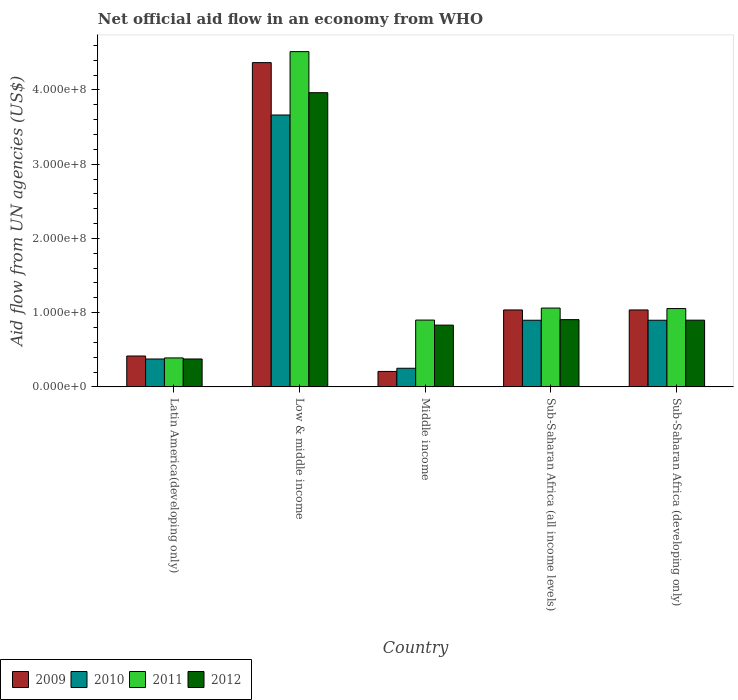How many different coloured bars are there?
Make the answer very short. 4. Are the number of bars per tick equal to the number of legend labels?
Give a very brief answer. Yes. How many bars are there on the 5th tick from the right?
Provide a short and direct response. 4. What is the label of the 4th group of bars from the left?
Your answer should be compact. Sub-Saharan Africa (all income levels). What is the net official aid flow in 2009 in Sub-Saharan Africa (developing only)?
Ensure brevity in your answer.  1.04e+08. Across all countries, what is the maximum net official aid flow in 2009?
Ensure brevity in your answer.  4.37e+08. Across all countries, what is the minimum net official aid flow in 2012?
Ensure brevity in your answer.  3.76e+07. In which country was the net official aid flow in 2011 minimum?
Provide a short and direct response. Latin America(developing only). What is the total net official aid flow in 2010 in the graph?
Give a very brief answer. 6.08e+08. What is the difference between the net official aid flow in 2012 in Latin America(developing only) and that in Sub-Saharan Africa (all income levels)?
Offer a terse response. -5.30e+07. What is the difference between the net official aid flow in 2011 in Low & middle income and the net official aid flow in 2009 in Middle income?
Provide a short and direct response. 4.31e+08. What is the average net official aid flow in 2012 per country?
Offer a very short reply. 1.39e+08. What is the difference between the net official aid flow of/in 2010 and net official aid flow of/in 2009 in Middle income?
Provide a succinct answer. 4.27e+06. What is the ratio of the net official aid flow in 2009 in Latin America(developing only) to that in Sub-Saharan Africa (all income levels)?
Give a very brief answer. 0.4. Is the net official aid flow in 2011 in Low & middle income less than that in Middle income?
Your answer should be very brief. No. What is the difference between the highest and the second highest net official aid flow in 2010?
Your answer should be very brief. 2.76e+08. What is the difference between the highest and the lowest net official aid flow in 2012?
Offer a terse response. 3.59e+08. In how many countries, is the net official aid flow in 2012 greater than the average net official aid flow in 2012 taken over all countries?
Keep it short and to the point. 1. What does the 3rd bar from the left in Sub-Saharan Africa (developing only) represents?
Your response must be concise. 2011. How many countries are there in the graph?
Your answer should be compact. 5. Are the values on the major ticks of Y-axis written in scientific E-notation?
Offer a very short reply. Yes. Does the graph contain any zero values?
Keep it short and to the point. No. Does the graph contain grids?
Make the answer very short. No. How many legend labels are there?
Provide a short and direct response. 4. How are the legend labels stacked?
Keep it short and to the point. Horizontal. What is the title of the graph?
Give a very brief answer. Net official aid flow in an economy from WHO. What is the label or title of the X-axis?
Provide a succinct answer. Country. What is the label or title of the Y-axis?
Ensure brevity in your answer.  Aid flow from UN agencies (US$). What is the Aid flow from UN agencies (US$) in 2009 in Latin America(developing only)?
Keep it short and to the point. 4.16e+07. What is the Aid flow from UN agencies (US$) in 2010 in Latin America(developing only)?
Offer a terse response. 3.76e+07. What is the Aid flow from UN agencies (US$) in 2011 in Latin America(developing only)?
Your response must be concise. 3.90e+07. What is the Aid flow from UN agencies (US$) of 2012 in Latin America(developing only)?
Provide a short and direct response. 3.76e+07. What is the Aid flow from UN agencies (US$) of 2009 in Low & middle income?
Your answer should be very brief. 4.37e+08. What is the Aid flow from UN agencies (US$) in 2010 in Low & middle income?
Keep it short and to the point. 3.66e+08. What is the Aid flow from UN agencies (US$) of 2011 in Low & middle income?
Keep it short and to the point. 4.52e+08. What is the Aid flow from UN agencies (US$) of 2012 in Low & middle income?
Keep it short and to the point. 3.96e+08. What is the Aid flow from UN agencies (US$) of 2009 in Middle income?
Offer a very short reply. 2.08e+07. What is the Aid flow from UN agencies (US$) in 2010 in Middle income?
Provide a succinct answer. 2.51e+07. What is the Aid flow from UN agencies (US$) of 2011 in Middle income?
Your answer should be compact. 9.00e+07. What is the Aid flow from UN agencies (US$) in 2012 in Middle income?
Ensure brevity in your answer.  8.32e+07. What is the Aid flow from UN agencies (US$) in 2009 in Sub-Saharan Africa (all income levels)?
Offer a very short reply. 1.04e+08. What is the Aid flow from UN agencies (US$) of 2010 in Sub-Saharan Africa (all income levels)?
Provide a short and direct response. 8.98e+07. What is the Aid flow from UN agencies (US$) in 2011 in Sub-Saharan Africa (all income levels)?
Provide a short and direct response. 1.06e+08. What is the Aid flow from UN agencies (US$) of 2012 in Sub-Saharan Africa (all income levels)?
Keep it short and to the point. 9.06e+07. What is the Aid flow from UN agencies (US$) of 2009 in Sub-Saharan Africa (developing only)?
Your answer should be compact. 1.04e+08. What is the Aid flow from UN agencies (US$) in 2010 in Sub-Saharan Africa (developing only)?
Your answer should be compact. 8.98e+07. What is the Aid flow from UN agencies (US$) in 2011 in Sub-Saharan Africa (developing only)?
Provide a short and direct response. 1.05e+08. What is the Aid flow from UN agencies (US$) in 2012 in Sub-Saharan Africa (developing only)?
Provide a short and direct response. 8.98e+07. Across all countries, what is the maximum Aid flow from UN agencies (US$) of 2009?
Ensure brevity in your answer.  4.37e+08. Across all countries, what is the maximum Aid flow from UN agencies (US$) in 2010?
Provide a succinct answer. 3.66e+08. Across all countries, what is the maximum Aid flow from UN agencies (US$) of 2011?
Keep it short and to the point. 4.52e+08. Across all countries, what is the maximum Aid flow from UN agencies (US$) in 2012?
Offer a terse response. 3.96e+08. Across all countries, what is the minimum Aid flow from UN agencies (US$) of 2009?
Your response must be concise. 2.08e+07. Across all countries, what is the minimum Aid flow from UN agencies (US$) in 2010?
Keep it short and to the point. 2.51e+07. Across all countries, what is the minimum Aid flow from UN agencies (US$) in 2011?
Give a very brief answer. 3.90e+07. Across all countries, what is the minimum Aid flow from UN agencies (US$) of 2012?
Give a very brief answer. 3.76e+07. What is the total Aid flow from UN agencies (US$) of 2009 in the graph?
Give a very brief answer. 7.06e+08. What is the total Aid flow from UN agencies (US$) of 2010 in the graph?
Provide a short and direct response. 6.08e+08. What is the total Aid flow from UN agencies (US$) in 2011 in the graph?
Offer a terse response. 7.92e+08. What is the total Aid flow from UN agencies (US$) in 2012 in the graph?
Your response must be concise. 6.97e+08. What is the difference between the Aid flow from UN agencies (US$) of 2009 in Latin America(developing only) and that in Low & middle income?
Provide a succinct answer. -3.95e+08. What is the difference between the Aid flow from UN agencies (US$) in 2010 in Latin America(developing only) and that in Low & middle income?
Provide a short and direct response. -3.29e+08. What is the difference between the Aid flow from UN agencies (US$) in 2011 in Latin America(developing only) and that in Low & middle income?
Make the answer very short. -4.13e+08. What is the difference between the Aid flow from UN agencies (US$) in 2012 in Latin America(developing only) and that in Low & middle income?
Ensure brevity in your answer.  -3.59e+08. What is the difference between the Aid flow from UN agencies (US$) in 2009 in Latin America(developing only) and that in Middle income?
Make the answer very short. 2.08e+07. What is the difference between the Aid flow from UN agencies (US$) in 2010 in Latin America(developing only) and that in Middle income?
Offer a terse response. 1.25e+07. What is the difference between the Aid flow from UN agencies (US$) of 2011 in Latin America(developing only) and that in Middle income?
Provide a succinct answer. -5.10e+07. What is the difference between the Aid flow from UN agencies (US$) of 2012 in Latin America(developing only) and that in Middle income?
Give a very brief answer. -4.56e+07. What is the difference between the Aid flow from UN agencies (US$) in 2009 in Latin America(developing only) and that in Sub-Saharan Africa (all income levels)?
Your answer should be compact. -6.20e+07. What is the difference between the Aid flow from UN agencies (US$) in 2010 in Latin America(developing only) and that in Sub-Saharan Africa (all income levels)?
Keep it short and to the point. -5.22e+07. What is the difference between the Aid flow from UN agencies (US$) in 2011 in Latin America(developing only) and that in Sub-Saharan Africa (all income levels)?
Your answer should be very brief. -6.72e+07. What is the difference between the Aid flow from UN agencies (US$) in 2012 in Latin America(developing only) and that in Sub-Saharan Africa (all income levels)?
Provide a short and direct response. -5.30e+07. What is the difference between the Aid flow from UN agencies (US$) of 2009 in Latin America(developing only) and that in Sub-Saharan Africa (developing only)?
Provide a short and direct response. -6.20e+07. What is the difference between the Aid flow from UN agencies (US$) of 2010 in Latin America(developing only) and that in Sub-Saharan Africa (developing only)?
Your answer should be compact. -5.22e+07. What is the difference between the Aid flow from UN agencies (US$) in 2011 in Latin America(developing only) and that in Sub-Saharan Africa (developing only)?
Keep it short and to the point. -6.65e+07. What is the difference between the Aid flow from UN agencies (US$) of 2012 in Latin America(developing only) and that in Sub-Saharan Africa (developing only)?
Your answer should be compact. -5.23e+07. What is the difference between the Aid flow from UN agencies (US$) in 2009 in Low & middle income and that in Middle income?
Offer a very short reply. 4.16e+08. What is the difference between the Aid flow from UN agencies (US$) of 2010 in Low & middle income and that in Middle income?
Provide a short and direct response. 3.41e+08. What is the difference between the Aid flow from UN agencies (US$) in 2011 in Low & middle income and that in Middle income?
Your answer should be compact. 3.62e+08. What is the difference between the Aid flow from UN agencies (US$) of 2012 in Low & middle income and that in Middle income?
Provide a succinct answer. 3.13e+08. What is the difference between the Aid flow from UN agencies (US$) in 2009 in Low & middle income and that in Sub-Saharan Africa (all income levels)?
Your response must be concise. 3.33e+08. What is the difference between the Aid flow from UN agencies (US$) in 2010 in Low & middle income and that in Sub-Saharan Africa (all income levels)?
Your answer should be compact. 2.76e+08. What is the difference between the Aid flow from UN agencies (US$) in 2011 in Low & middle income and that in Sub-Saharan Africa (all income levels)?
Make the answer very short. 3.45e+08. What is the difference between the Aid flow from UN agencies (US$) of 2012 in Low & middle income and that in Sub-Saharan Africa (all income levels)?
Ensure brevity in your answer.  3.06e+08. What is the difference between the Aid flow from UN agencies (US$) in 2009 in Low & middle income and that in Sub-Saharan Africa (developing only)?
Make the answer very short. 3.33e+08. What is the difference between the Aid flow from UN agencies (US$) of 2010 in Low & middle income and that in Sub-Saharan Africa (developing only)?
Your answer should be compact. 2.76e+08. What is the difference between the Aid flow from UN agencies (US$) in 2011 in Low & middle income and that in Sub-Saharan Africa (developing only)?
Provide a short and direct response. 3.46e+08. What is the difference between the Aid flow from UN agencies (US$) in 2012 in Low & middle income and that in Sub-Saharan Africa (developing only)?
Your answer should be very brief. 3.06e+08. What is the difference between the Aid flow from UN agencies (US$) of 2009 in Middle income and that in Sub-Saharan Africa (all income levels)?
Your answer should be very brief. -8.28e+07. What is the difference between the Aid flow from UN agencies (US$) of 2010 in Middle income and that in Sub-Saharan Africa (all income levels)?
Make the answer very short. -6.47e+07. What is the difference between the Aid flow from UN agencies (US$) in 2011 in Middle income and that in Sub-Saharan Africa (all income levels)?
Your response must be concise. -1.62e+07. What is the difference between the Aid flow from UN agencies (US$) in 2012 in Middle income and that in Sub-Saharan Africa (all income levels)?
Your answer should be very brief. -7.39e+06. What is the difference between the Aid flow from UN agencies (US$) in 2009 in Middle income and that in Sub-Saharan Africa (developing only)?
Your response must be concise. -8.28e+07. What is the difference between the Aid flow from UN agencies (US$) of 2010 in Middle income and that in Sub-Saharan Africa (developing only)?
Give a very brief answer. -6.47e+07. What is the difference between the Aid flow from UN agencies (US$) in 2011 in Middle income and that in Sub-Saharan Africa (developing only)?
Provide a succinct answer. -1.55e+07. What is the difference between the Aid flow from UN agencies (US$) of 2012 in Middle income and that in Sub-Saharan Africa (developing only)?
Offer a very short reply. -6.67e+06. What is the difference between the Aid flow from UN agencies (US$) in 2009 in Sub-Saharan Africa (all income levels) and that in Sub-Saharan Africa (developing only)?
Provide a succinct answer. 0. What is the difference between the Aid flow from UN agencies (US$) in 2010 in Sub-Saharan Africa (all income levels) and that in Sub-Saharan Africa (developing only)?
Offer a very short reply. 0. What is the difference between the Aid flow from UN agencies (US$) of 2011 in Sub-Saharan Africa (all income levels) and that in Sub-Saharan Africa (developing only)?
Ensure brevity in your answer.  6.70e+05. What is the difference between the Aid flow from UN agencies (US$) in 2012 in Sub-Saharan Africa (all income levels) and that in Sub-Saharan Africa (developing only)?
Your answer should be very brief. 7.20e+05. What is the difference between the Aid flow from UN agencies (US$) of 2009 in Latin America(developing only) and the Aid flow from UN agencies (US$) of 2010 in Low & middle income?
Offer a terse response. -3.25e+08. What is the difference between the Aid flow from UN agencies (US$) of 2009 in Latin America(developing only) and the Aid flow from UN agencies (US$) of 2011 in Low & middle income?
Offer a terse response. -4.10e+08. What is the difference between the Aid flow from UN agencies (US$) of 2009 in Latin America(developing only) and the Aid flow from UN agencies (US$) of 2012 in Low & middle income?
Your answer should be compact. -3.55e+08. What is the difference between the Aid flow from UN agencies (US$) of 2010 in Latin America(developing only) and the Aid flow from UN agencies (US$) of 2011 in Low & middle income?
Your response must be concise. -4.14e+08. What is the difference between the Aid flow from UN agencies (US$) of 2010 in Latin America(developing only) and the Aid flow from UN agencies (US$) of 2012 in Low & middle income?
Provide a short and direct response. -3.59e+08. What is the difference between the Aid flow from UN agencies (US$) in 2011 in Latin America(developing only) and the Aid flow from UN agencies (US$) in 2012 in Low & middle income?
Your response must be concise. -3.57e+08. What is the difference between the Aid flow from UN agencies (US$) of 2009 in Latin America(developing only) and the Aid flow from UN agencies (US$) of 2010 in Middle income?
Keep it short and to the point. 1.65e+07. What is the difference between the Aid flow from UN agencies (US$) of 2009 in Latin America(developing only) and the Aid flow from UN agencies (US$) of 2011 in Middle income?
Offer a very short reply. -4.84e+07. What is the difference between the Aid flow from UN agencies (US$) in 2009 in Latin America(developing only) and the Aid flow from UN agencies (US$) in 2012 in Middle income?
Ensure brevity in your answer.  -4.16e+07. What is the difference between the Aid flow from UN agencies (US$) of 2010 in Latin America(developing only) and the Aid flow from UN agencies (US$) of 2011 in Middle income?
Your response must be concise. -5.24e+07. What is the difference between the Aid flow from UN agencies (US$) of 2010 in Latin America(developing only) and the Aid flow from UN agencies (US$) of 2012 in Middle income?
Give a very brief answer. -4.56e+07. What is the difference between the Aid flow from UN agencies (US$) of 2011 in Latin America(developing only) and the Aid flow from UN agencies (US$) of 2012 in Middle income?
Provide a succinct answer. -4.42e+07. What is the difference between the Aid flow from UN agencies (US$) in 2009 in Latin America(developing only) and the Aid flow from UN agencies (US$) in 2010 in Sub-Saharan Africa (all income levels)?
Keep it short and to the point. -4.82e+07. What is the difference between the Aid flow from UN agencies (US$) in 2009 in Latin America(developing only) and the Aid flow from UN agencies (US$) in 2011 in Sub-Saharan Africa (all income levels)?
Your answer should be compact. -6.46e+07. What is the difference between the Aid flow from UN agencies (US$) in 2009 in Latin America(developing only) and the Aid flow from UN agencies (US$) in 2012 in Sub-Saharan Africa (all income levels)?
Your answer should be compact. -4.90e+07. What is the difference between the Aid flow from UN agencies (US$) of 2010 in Latin America(developing only) and the Aid flow from UN agencies (US$) of 2011 in Sub-Saharan Africa (all income levels)?
Provide a short and direct response. -6.86e+07. What is the difference between the Aid flow from UN agencies (US$) in 2010 in Latin America(developing only) and the Aid flow from UN agencies (US$) in 2012 in Sub-Saharan Africa (all income levels)?
Give a very brief answer. -5.30e+07. What is the difference between the Aid flow from UN agencies (US$) of 2011 in Latin America(developing only) and the Aid flow from UN agencies (US$) of 2012 in Sub-Saharan Africa (all income levels)?
Make the answer very short. -5.16e+07. What is the difference between the Aid flow from UN agencies (US$) in 2009 in Latin America(developing only) and the Aid flow from UN agencies (US$) in 2010 in Sub-Saharan Africa (developing only)?
Offer a very short reply. -4.82e+07. What is the difference between the Aid flow from UN agencies (US$) in 2009 in Latin America(developing only) and the Aid flow from UN agencies (US$) in 2011 in Sub-Saharan Africa (developing only)?
Give a very brief answer. -6.39e+07. What is the difference between the Aid flow from UN agencies (US$) in 2009 in Latin America(developing only) and the Aid flow from UN agencies (US$) in 2012 in Sub-Saharan Africa (developing only)?
Your response must be concise. -4.83e+07. What is the difference between the Aid flow from UN agencies (US$) of 2010 in Latin America(developing only) and the Aid flow from UN agencies (US$) of 2011 in Sub-Saharan Africa (developing only)?
Offer a terse response. -6.79e+07. What is the difference between the Aid flow from UN agencies (US$) in 2010 in Latin America(developing only) and the Aid flow from UN agencies (US$) in 2012 in Sub-Saharan Africa (developing only)?
Your answer should be compact. -5.23e+07. What is the difference between the Aid flow from UN agencies (US$) of 2011 in Latin America(developing only) and the Aid flow from UN agencies (US$) of 2012 in Sub-Saharan Africa (developing only)?
Your answer should be compact. -5.09e+07. What is the difference between the Aid flow from UN agencies (US$) of 2009 in Low & middle income and the Aid flow from UN agencies (US$) of 2010 in Middle income?
Offer a terse response. 4.12e+08. What is the difference between the Aid flow from UN agencies (US$) in 2009 in Low & middle income and the Aid flow from UN agencies (US$) in 2011 in Middle income?
Your answer should be very brief. 3.47e+08. What is the difference between the Aid flow from UN agencies (US$) in 2009 in Low & middle income and the Aid flow from UN agencies (US$) in 2012 in Middle income?
Your answer should be compact. 3.54e+08. What is the difference between the Aid flow from UN agencies (US$) in 2010 in Low & middle income and the Aid flow from UN agencies (US$) in 2011 in Middle income?
Keep it short and to the point. 2.76e+08. What is the difference between the Aid flow from UN agencies (US$) in 2010 in Low & middle income and the Aid flow from UN agencies (US$) in 2012 in Middle income?
Offer a terse response. 2.83e+08. What is the difference between the Aid flow from UN agencies (US$) of 2011 in Low & middle income and the Aid flow from UN agencies (US$) of 2012 in Middle income?
Keep it short and to the point. 3.68e+08. What is the difference between the Aid flow from UN agencies (US$) in 2009 in Low & middle income and the Aid flow from UN agencies (US$) in 2010 in Sub-Saharan Africa (all income levels)?
Ensure brevity in your answer.  3.47e+08. What is the difference between the Aid flow from UN agencies (US$) of 2009 in Low & middle income and the Aid flow from UN agencies (US$) of 2011 in Sub-Saharan Africa (all income levels)?
Provide a short and direct response. 3.31e+08. What is the difference between the Aid flow from UN agencies (US$) in 2009 in Low & middle income and the Aid flow from UN agencies (US$) in 2012 in Sub-Saharan Africa (all income levels)?
Give a very brief answer. 3.46e+08. What is the difference between the Aid flow from UN agencies (US$) of 2010 in Low & middle income and the Aid flow from UN agencies (US$) of 2011 in Sub-Saharan Africa (all income levels)?
Offer a very short reply. 2.60e+08. What is the difference between the Aid flow from UN agencies (US$) of 2010 in Low & middle income and the Aid flow from UN agencies (US$) of 2012 in Sub-Saharan Africa (all income levels)?
Keep it short and to the point. 2.76e+08. What is the difference between the Aid flow from UN agencies (US$) in 2011 in Low & middle income and the Aid flow from UN agencies (US$) in 2012 in Sub-Saharan Africa (all income levels)?
Your answer should be very brief. 3.61e+08. What is the difference between the Aid flow from UN agencies (US$) of 2009 in Low & middle income and the Aid flow from UN agencies (US$) of 2010 in Sub-Saharan Africa (developing only)?
Offer a very short reply. 3.47e+08. What is the difference between the Aid flow from UN agencies (US$) in 2009 in Low & middle income and the Aid flow from UN agencies (US$) in 2011 in Sub-Saharan Africa (developing only)?
Give a very brief answer. 3.31e+08. What is the difference between the Aid flow from UN agencies (US$) in 2009 in Low & middle income and the Aid flow from UN agencies (US$) in 2012 in Sub-Saharan Africa (developing only)?
Make the answer very short. 3.47e+08. What is the difference between the Aid flow from UN agencies (US$) in 2010 in Low & middle income and the Aid flow from UN agencies (US$) in 2011 in Sub-Saharan Africa (developing only)?
Give a very brief answer. 2.61e+08. What is the difference between the Aid flow from UN agencies (US$) of 2010 in Low & middle income and the Aid flow from UN agencies (US$) of 2012 in Sub-Saharan Africa (developing only)?
Give a very brief answer. 2.76e+08. What is the difference between the Aid flow from UN agencies (US$) of 2011 in Low & middle income and the Aid flow from UN agencies (US$) of 2012 in Sub-Saharan Africa (developing only)?
Keep it short and to the point. 3.62e+08. What is the difference between the Aid flow from UN agencies (US$) in 2009 in Middle income and the Aid flow from UN agencies (US$) in 2010 in Sub-Saharan Africa (all income levels)?
Provide a succinct answer. -6.90e+07. What is the difference between the Aid flow from UN agencies (US$) of 2009 in Middle income and the Aid flow from UN agencies (US$) of 2011 in Sub-Saharan Africa (all income levels)?
Offer a very short reply. -8.54e+07. What is the difference between the Aid flow from UN agencies (US$) in 2009 in Middle income and the Aid flow from UN agencies (US$) in 2012 in Sub-Saharan Africa (all income levels)?
Your response must be concise. -6.98e+07. What is the difference between the Aid flow from UN agencies (US$) of 2010 in Middle income and the Aid flow from UN agencies (US$) of 2011 in Sub-Saharan Africa (all income levels)?
Offer a terse response. -8.11e+07. What is the difference between the Aid flow from UN agencies (US$) of 2010 in Middle income and the Aid flow from UN agencies (US$) of 2012 in Sub-Saharan Africa (all income levels)?
Your answer should be very brief. -6.55e+07. What is the difference between the Aid flow from UN agencies (US$) of 2011 in Middle income and the Aid flow from UN agencies (US$) of 2012 in Sub-Saharan Africa (all income levels)?
Provide a succinct answer. -5.90e+05. What is the difference between the Aid flow from UN agencies (US$) in 2009 in Middle income and the Aid flow from UN agencies (US$) in 2010 in Sub-Saharan Africa (developing only)?
Offer a terse response. -6.90e+07. What is the difference between the Aid flow from UN agencies (US$) in 2009 in Middle income and the Aid flow from UN agencies (US$) in 2011 in Sub-Saharan Africa (developing only)?
Offer a terse response. -8.47e+07. What is the difference between the Aid flow from UN agencies (US$) of 2009 in Middle income and the Aid flow from UN agencies (US$) of 2012 in Sub-Saharan Africa (developing only)?
Your answer should be very brief. -6.90e+07. What is the difference between the Aid flow from UN agencies (US$) of 2010 in Middle income and the Aid flow from UN agencies (US$) of 2011 in Sub-Saharan Africa (developing only)?
Offer a terse response. -8.04e+07. What is the difference between the Aid flow from UN agencies (US$) in 2010 in Middle income and the Aid flow from UN agencies (US$) in 2012 in Sub-Saharan Africa (developing only)?
Provide a succinct answer. -6.48e+07. What is the difference between the Aid flow from UN agencies (US$) of 2011 in Middle income and the Aid flow from UN agencies (US$) of 2012 in Sub-Saharan Africa (developing only)?
Your answer should be very brief. 1.30e+05. What is the difference between the Aid flow from UN agencies (US$) of 2009 in Sub-Saharan Africa (all income levels) and the Aid flow from UN agencies (US$) of 2010 in Sub-Saharan Africa (developing only)?
Your answer should be very brief. 1.39e+07. What is the difference between the Aid flow from UN agencies (US$) of 2009 in Sub-Saharan Africa (all income levels) and the Aid flow from UN agencies (US$) of 2011 in Sub-Saharan Africa (developing only)?
Offer a very short reply. -1.86e+06. What is the difference between the Aid flow from UN agencies (US$) in 2009 in Sub-Saharan Africa (all income levels) and the Aid flow from UN agencies (US$) in 2012 in Sub-Saharan Africa (developing only)?
Your answer should be compact. 1.38e+07. What is the difference between the Aid flow from UN agencies (US$) of 2010 in Sub-Saharan Africa (all income levels) and the Aid flow from UN agencies (US$) of 2011 in Sub-Saharan Africa (developing only)?
Make the answer very short. -1.57e+07. What is the difference between the Aid flow from UN agencies (US$) in 2010 in Sub-Saharan Africa (all income levels) and the Aid flow from UN agencies (US$) in 2012 in Sub-Saharan Africa (developing only)?
Give a very brief answer. -9.00e+04. What is the difference between the Aid flow from UN agencies (US$) of 2011 in Sub-Saharan Africa (all income levels) and the Aid flow from UN agencies (US$) of 2012 in Sub-Saharan Africa (developing only)?
Provide a succinct answer. 1.63e+07. What is the average Aid flow from UN agencies (US$) of 2009 per country?
Provide a short and direct response. 1.41e+08. What is the average Aid flow from UN agencies (US$) in 2010 per country?
Keep it short and to the point. 1.22e+08. What is the average Aid flow from UN agencies (US$) of 2011 per country?
Ensure brevity in your answer.  1.58e+08. What is the average Aid flow from UN agencies (US$) of 2012 per country?
Your response must be concise. 1.39e+08. What is the difference between the Aid flow from UN agencies (US$) of 2009 and Aid flow from UN agencies (US$) of 2010 in Latin America(developing only)?
Offer a very short reply. 4.01e+06. What is the difference between the Aid flow from UN agencies (US$) of 2009 and Aid flow from UN agencies (US$) of 2011 in Latin America(developing only)?
Your answer should be compact. 2.59e+06. What is the difference between the Aid flow from UN agencies (US$) in 2009 and Aid flow from UN agencies (US$) in 2012 in Latin America(developing only)?
Your response must be concise. 3.99e+06. What is the difference between the Aid flow from UN agencies (US$) of 2010 and Aid flow from UN agencies (US$) of 2011 in Latin America(developing only)?
Ensure brevity in your answer.  -1.42e+06. What is the difference between the Aid flow from UN agencies (US$) in 2010 and Aid flow from UN agencies (US$) in 2012 in Latin America(developing only)?
Your response must be concise. -2.00e+04. What is the difference between the Aid flow from UN agencies (US$) in 2011 and Aid flow from UN agencies (US$) in 2012 in Latin America(developing only)?
Ensure brevity in your answer.  1.40e+06. What is the difference between the Aid flow from UN agencies (US$) in 2009 and Aid flow from UN agencies (US$) in 2010 in Low & middle income?
Provide a short and direct response. 7.06e+07. What is the difference between the Aid flow from UN agencies (US$) of 2009 and Aid flow from UN agencies (US$) of 2011 in Low & middle income?
Give a very brief answer. -1.48e+07. What is the difference between the Aid flow from UN agencies (US$) of 2009 and Aid flow from UN agencies (US$) of 2012 in Low & middle income?
Provide a short and direct response. 4.05e+07. What is the difference between the Aid flow from UN agencies (US$) in 2010 and Aid flow from UN agencies (US$) in 2011 in Low & middle income?
Provide a short and direct response. -8.54e+07. What is the difference between the Aid flow from UN agencies (US$) of 2010 and Aid flow from UN agencies (US$) of 2012 in Low & middle income?
Provide a short and direct response. -3.00e+07. What is the difference between the Aid flow from UN agencies (US$) of 2011 and Aid flow from UN agencies (US$) of 2012 in Low & middle income?
Keep it short and to the point. 5.53e+07. What is the difference between the Aid flow from UN agencies (US$) of 2009 and Aid flow from UN agencies (US$) of 2010 in Middle income?
Your answer should be compact. -4.27e+06. What is the difference between the Aid flow from UN agencies (US$) in 2009 and Aid flow from UN agencies (US$) in 2011 in Middle income?
Your answer should be compact. -6.92e+07. What is the difference between the Aid flow from UN agencies (US$) of 2009 and Aid flow from UN agencies (US$) of 2012 in Middle income?
Provide a short and direct response. -6.24e+07. What is the difference between the Aid flow from UN agencies (US$) in 2010 and Aid flow from UN agencies (US$) in 2011 in Middle income?
Give a very brief answer. -6.49e+07. What is the difference between the Aid flow from UN agencies (US$) of 2010 and Aid flow from UN agencies (US$) of 2012 in Middle income?
Offer a very short reply. -5.81e+07. What is the difference between the Aid flow from UN agencies (US$) of 2011 and Aid flow from UN agencies (US$) of 2012 in Middle income?
Offer a very short reply. 6.80e+06. What is the difference between the Aid flow from UN agencies (US$) of 2009 and Aid flow from UN agencies (US$) of 2010 in Sub-Saharan Africa (all income levels)?
Keep it short and to the point. 1.39e+07. What is the difference between the Aid flow from UN agencies (US$) in 2009 and Aid flow from UN agencies (US$) in 2011 in Sub-Saharan Africa (all income levels)?
Provide a short and direct response. -2.53e+06. What is the difference between the Aid flow from UN agencies (US$) of 2009 and Aid flow from UN agencies (US$) of 2012 in Sub-Saharan Africa (all income levels)?
Offer a very short reply. 1.30e+07. What is the difference between the Aid flow from UN agencies (US$) of 2010 and Aid flow from UN agencies (US$) of 2011 in Sub-Saharan Africa (all income levels)?
Your answer should be compact. -1.64e+07. What is the difference between the Aid flow from UN agencies (US$) of 2010 and Aid flow from UN agencies (US$) of 2012 in Sub-Saharan Africa (all income levels)?
Provide a short and direct response. -8.10e+05. What is the difference between the Aid flow from UN agencies (US$) of 2011 and Aid flow from UN agencies (US$) of 2012 in Sub-Saharan Africa (all income levels)?
Your response must be concise. 1.56e+07. What is the difference between the Aid flow from UN agencies (US$) of 2009 and Aid flow from UN agencies (US$) of 2010 in Sub-Saharan Africa (developing only)?
Your answer should be compact. 1.39e+07. What is the difference between the Aid flow from UN agencies (US$) of 2009 and Aid flow from UN agencies (US$) of 2011 in Sub-Saharan Africa (developing only)?
Provide a succinct answer. -1.86e+06. What is the difference between the Aid flow from UN agencies (US$) of 2009 and Aid flow from UN agencies (US$) of 2012 in Sub-Saharan Africa (developing only)?
Offer a terse response. 1.38e+07. What is the difference between the Aid flow from UN agencies (US$) of 2010 and Aid flow from UN agencies (US$) of 2011 in Sub-Saharan Africa (developing only)?
Provide a short and direct response. -1.57e+07. What is the difference between the Aid flow from UN agencies (US$) of 2010 and Aid flow from UN agencies (US$) of 2012 in Sub-Saharan Africa (developing only)?
Offer a very short reply. -9.00e+04. What is the difference between the Aid flow from UN agencies (US$) of 2011 and Aid flow from UN agencies (US$) of 2012 in Sub-Saharan Africa (developing only)?
Your answer should be very brief. 1.56e+07. What is the ratio of the Aid flow from UN agencies (US$) in 2009 in Latin America(developing only) to that in Low & middle income?
Your response must be concise. 0.1. What is the ratio of the Aid flow from UN agencies (US$) of 2010 in Latin America(developing only) to that in Low & middle income?
Provide a short and direct response. 0.1. What is the ratio of the Aid flow from UN agencies (US$) of 2011 in Latin America(developing only) to that in Low & middle income?
Offer a very short reply. 0.09. What is the ratio of the Aid flow from UN agencies (US$) in 2012 in Latin America(developing only) to that in Low & middle income?
Keep it short and to the point. 0.09. What is the ratio of the Aid flow from UN agencies (US$) of 2009 in Latin America(developing only) to that in Middle income?
Your answer should be compact. 2. What is the ratio of the Aid flow from UN agencies (US$) in 2010 in Latin America(developing only) to that in Middle income?
Make the answer very short. 1.5. What is the ratio of the Aid flow from UN agencies (US$) in 2011 in Latin America(developing only) to that in Middle income?
Offer a very short reply. 0.43. What is the ratio of the Aid flow from UN agencies (US$) in 2012 in Latin America(developing only) to that in Middle income?
Offer a very short reply. 0.45. What is the ratio of the Aid flow from UN agencies (US$) of 2009 in Latin America(developing only) to that in Sub-Saharan Africa (all income levels)?
Offer a very short reply. 0.4. What is the ratio of the Aid flow from UN agencies (US$) in 2010 in Latin America(developing only) to that in Sub-Saharan Africa (all income levels)?
Provide a succinct answer. 0.42. What is the ratio of the Aid flow from UN agencies (US$) of 2011 in Latin America(developing only) to that in Sub-Saharan Africa (all income levels)?
Offer a very short reply. 0.37. What is the ratio of the Aid flow from UN agencies (US$) of 2012 in Latin America(developing only) to that in Sub-Saharan Africa (all income levels)?
Make the answer very short. 0.41. What is the ratio of the Aid flow from UN agencies (US$) in 2009 in Latin America(developing only) to that in Sub-Saharan Africa (developing only)?
Offer a very short reply. 0.4. What is the ratio of the Aid flow from UN agencies (US$) of 2010 in Latin America(developing only) to that in Sub-Saharan Africa (developing only)?
Provide a short and direct response. 0.42. What is the ratio of the Aid flow from UN agencies (US$) of 2011 in Latin America(developing only) to that in Sub-Saharan Africa (developing only)?
Your answer should be compact. 0.37. What is the ratio of the Aid flow from UN agencies (US$) of 2012 in Latin America(developing only) to that in Sub-Saharan Africa (developing only)?
Your response must be concise. 0.42. What is the ratio of the Aid flow from UN agencies (US$) in 2009 in Low & middle income to that in Middle income?
Provide a short and direct response. 21. What is the ratio of the Aid flow from UN agencies (US$) in 2010 in Low & middle income to that in Middle income?
Make the answer very short. 14.61. What is the ratio of the Aid flow from UN agencies (US$) of 2011 in Low & middle income to that in Middle income?
Make the answer very short. 5.02. What is the ratio of the Aid flow from UN agencies (US$) in 2012 in Low & middle income to that in Middle income?
Keep it short and to the point. 4.76. What is the ratio of the Aid flow from UN agencies (US$) of 2009 in Low & middle income to that in Sub-Saharan Africa (all income levels)?
Make the answer very short. 4.22. What is the ratio of the Aid flow from UN agencies (US$) of 2010 in Low & middle income to that in Sub-Saharan Africa (all income levels)?
Your answer should be compact. 4.08. What is the ratio of the Aid flow from UN agencies (US$) of 2011 in Low & middle income to that in Sub-Saharan Africa (all income levels)?
Your answer should be compact. 4.25. What is the ratio of the Aid flow from UN agencies (US$) in 2012 in Low & middle income to that in Sub-Saharan Africa (all income levels)?
Ensure brevity in your answer.  4.38. What is the ratio of the Aid flow from UN agencies (US$) in 2009 in Low & middle income to that in Sub-Saharan Africa (developing only)?
Give a very brief answer. 4.22. What is the ratio of the Aid flow from UN agencies (US$) of 2010 in Low & middle income to that in Sub-Saharan Africa (developing only)?
Make the answer very short. 4.08. What is the ratio of the Aid flow from UN agencies (US$) of 2011 in Low & middle income to that in Sub-Saharan Africa (developing only)?
Provide a short and direct response. 4.28. What is the ratio of the Aid flow from UN agencies (US$) in 2012 in Low & middle income to that in Sub-Saharan Africa (developing only)?
Keep it short and to the point. 4.41. What is the ratio of the Aid flow from UN agencies (US$) in 2009 in Middle income to that in Sub-Saharan Africa (all income levels)?
Provide a succinct answer. 0.2. What is the ratio of the Aid flow from UN agencies (US$) of 2010 in Middle income to that in Sub-Saharan Africa (all income levels)?
Provide a short and direct response. 0.28. What is the ratio of the Aid flow from UN agencies (US$) in 2011 in Middle income to that in Sub-Saharan Africa (all income levels)?
Provide a succinct answer. 0.85. What is the ratio of the Aid flow from UN agencies (US$) of 2012 in Middle income to that in Sub-Saharan Africa (all income levels)?
Your answer should be very brief. 0.92. What is the ratio of the Aid flow from UN agencies (US$) in 2009 in Middle income to that in Sub-Saharan Africa (developing only)?
Ensure brevity in your answer.  0.2. What is the ratio of the Aid flow from UN agencies (US$) of 2010 in Middle income to that in Sub-Saharan Africa (developing only)?
Offer a terse response. 0.28. What is the ratio of the Aid flow from UN agencies (US$) in 2011 in Middle income to that in Sub-Saharan Africa (developing only)?
Your answer should be very brief. 0.85. What is the ratio of the Aid flow from UN agencies (US$) in 2012 in Middle income to that in Sub-Saharan Africa (developing only)?
Make the answer very short. 0.93. What is the ratio of the Aid flow from UN agencies (US$) in 2011 in Sub-Saharan Africa (all income levels) to that in Sub-Saharan Africa (developing only)?
Ensure brevity in your answer.  1.01. What is the difference between the highest and the second highest Aid flow from UN agencies (US$) of 2009?
Provide a succinct answer. 3.33e+08. What is the difference between the highest and the second highest Aid flow from UN agencies (US$) of 2010?
Make the answer very short. 2.76e+08. What is the difference between the highest and the second highest Aid flow from UN agencies (US$) of 2011?
Offer a terse response. 3.45e+08. What is the difference between the highest and the second highest Aid flow from UN agencies (US$) of 2012?
Give a very brief answer. 3.06e+08. What is the difference between the highest and the lowest Aid flow from UN agencies (US$) in 2009?
Give a very brief answer. 4.16e+08. What is the difference between the highest and the lowest Aid flow from UN agencies (US$) in 2010?
Keep it short and to the point. 3.41e+08. What is the difference between the highest and the lowest Aid flow from UN agencies (US$) in 2011?
Offer a very short reply. 4.13e+08. What is the difference between the highest and the lowest Aid flow from UN agencies (US$) in 2012?
Provide a short and direct response. 3.59e+08. 